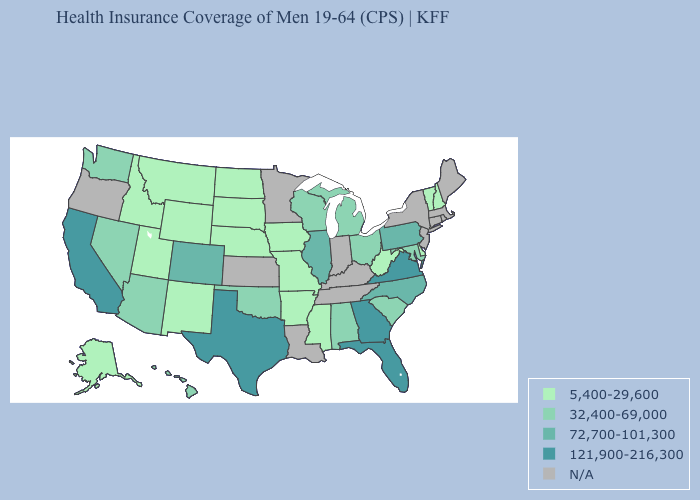Is the legend a continuous bar?
Be succinct. No. Among the states that border Utah , does Wyoming have the lowest value?
Concise answer only. Yes. Does the first symbol in the legend represent the smallest category?
Short answer required. Yes. What is the value of Illinois?
Concise answer only. 72,700-101,300. Which states have the lowest value in the Northeast?
Concise answer only. New Hampshire, Vermont. Which states have the lowest value in the Northeast?
Short answer required. New Hampshire, Vermont. Name the states that have a value in the range 5,400-29,600?
Quick response, please. Alaska, Arkansas, Delaware, Idaho, Iowa, Mississippi, Missouri, Montana, Nebraska, New Hampshire, New Mexico, North Dakota, South Dakota, Utah, Vermont, West Virginia, Wyoming. What is the lowest value in the MidWest?
Keep it brief. 5,400-29,600. Does Pennsylvania have the lowest value in the Northeast?
Quick response, please. No. Name the states that have a value in the range 121,900-216,300?
Give a very brief answer. California, Florida, Georgia, Texas, Virginia. What is the value of Idaho?
Answer briefly. 5,400-29,600. What is the lowest value in the South?
Write a very short answer. 5,400-29,600. Name the states that have a value in the range 72,700-101,300?
Quick response, please. Colorado, Illinois, North Carolina, Pennsylvania. Among the states that border South Carolina , which have the lowest value?
Be succinct. North Carolina. 